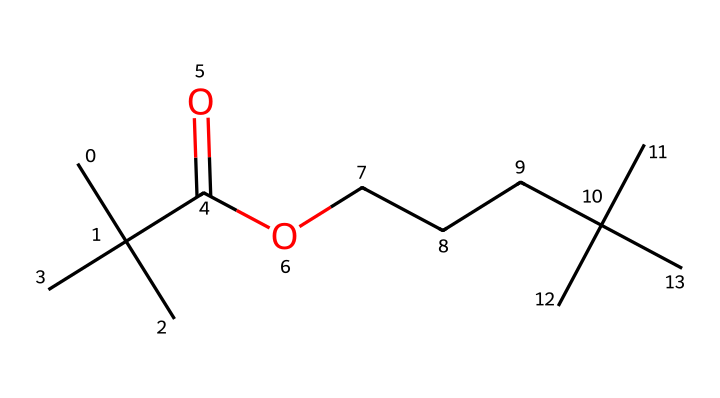What is the functional group present in this chemical? The chemical structure includes a carbonyl group (C=O) and a hydroxyl group (–OH) in the carboxylic acid segment. The presence of the –COOH indicates that this chemical contains a carboxylic acid functional group.
Answer: carboxylic acid How many carbon atoms are in this molecule? By analyzing the structure, we can count the carbon atoms. Considering the fragments and the backbone, there are a total of 12 carbon atoms present in this molecule.
Answer: 12 What type of bonds are primarily present in the backbone of this chemical? The backbone of the chemical consists mainly of single and double bonds between carbon atoms. The single bonds connect the carbon atoms in the chain, while the double bond is between one of the carbons and oxygen in the functional group.
Answer: single and double bonds What is the molecular formula for this chemical? To determine the molecular formula, we count all atoms present: 12 carbon (C), 24 hydrogen (H), and 2 oxygen (O) atoms, resulting in the formula C12H24O2.
Answer: C12H24O2 Does this chemical likely have adhesive properties? The presence of a carboxylic acid functional group indicates that this chemical can form hydrogen bonds with other materials, which is a typical characteristic for adhesives in bonding applications.
Answer: yes 